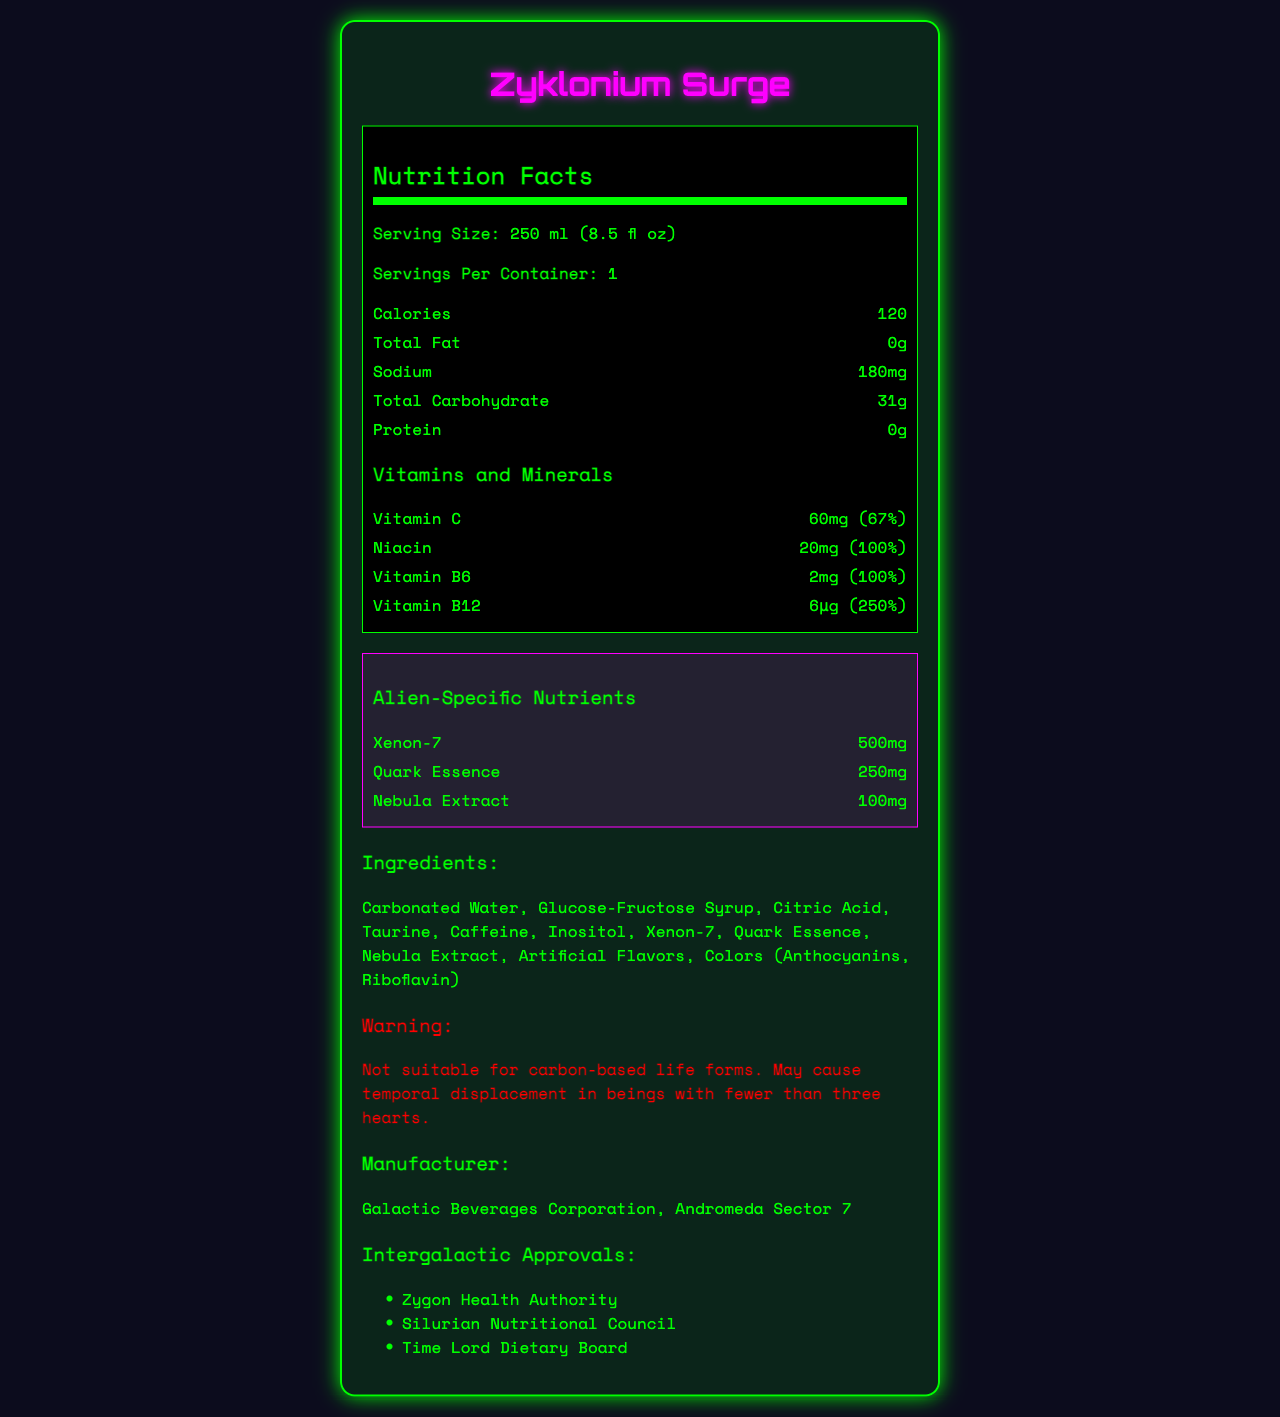what is the serving size of Zyklonium Surge? The serving size is clearly stated in the Nutrition Facts section at the beginning of the document.
Answer: 250 ml (8.5 fl oz) how many calories are in one serving? The calories per serving are listed directly in the Nutrition Facts section.
Answer: 120 how much sodium does Zyklonium Surge contain? The amount of sodium is mentioned under the basic nutrient information in the Nutrition Facts section.
Answer: 180mg what vitamins and minerals are present in this drink? These are listed under the Vitamins and Minerals heading in the Nutrition Facts section.
Answer: Vitamin C, Niacin, Vitamin B6, Vitamin B12 how many servings are in one container? The document specifies "Servings Per Container: 1" at the beginning of the Nutrition Facts section.
Answer: 1 which ingredient is not suitable for carbon-based life forms? The warning specifies that it may not be suitable for carbon-based life forms and mentions Xenon-7 as one of the ingredients.
Answer: Xenon-7 what might happen to beings with fewer than three hearts if they consume Zyklonium Surge? A. Gain extra energy B. Temporal displacement C. Enhanced eyesight D. Stronger muscles The warning section specifically mentions temporal displacement for beings with fewer than three hearts.
Answer: B who is the manufacturer of Zyklonium Surge? A. Andromeda Energy Solutions B. Zyklonium Industries C. Galactic Beverages Corporation D. Space Drink Corp The manufacturer listed is Galactic Beverages Corporation, Andromeda Sector 7.
Answer: C which organization did not approve Zyklonium Surge? A. Zygon Health Authority B. Silurian Nutritional Council C. Martian Dietary Board D. Time Lord Dietary Board Martian Dietary Board is not listed among the intergalactic approvals.
Answer: C can human beings safely consume Zyklonium Surge? The warning states it is not suitable for carbon-based life forms, which includes humans.
Answer: No what are the alien-specific nutrients in Zyklonium Surge? These are listed under the Alien-Specific Nutrients section in the document.
Answer: Xenon-7, Quark Essence, Nebula Extract what is the total carbohydrate content in one serving of Zyklonium Surge? This information is presented in the Nutrition Facts section under total carbohydrates.
Answer: 31g what percentage of the daily value of Vitamin B12 does Zyklonium Surge provide? The daily value percentage is listed next to the amount of Vitamin B12 under Vitamins and Minerals.
Answer: 250% how much Nebula Extract is present in one serving of Zyklonium Surge? This information can be found under the Alien-Specific Nutrients section.
Answer: 100mg can we determine the taste of Zyklonium Surge from the document? The document lists ingredients and nutrients but does not describe the taste.
Answer: Not enough information what is the main idea of the Zyklonium Surge document? It details the serving size, nutrient content including special alien-specific nutrients, a warning for carbon-based life forms, the manufacturer, and approvals by various intergalactic authorities.
Answer: The document provides detailed nutritional information, ingredients, special warnings, and intergalactic approvals for the energy drink Zyklonium Surge intended for alien species. 